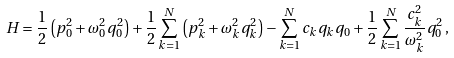Convert formula to latex. <formula><loc_0><loc_0><loc_500><loc_500>H = \frac { 1 } { 2 } \left ( p _ { 0 } ^ { 2 } + \omega _ { 0 } ^ { 2 } q _ { 0 } ^ { 2 } \right ) + \frac { 1 } { 2 } \sum _ { k = 1 } ^ { N } \left ( p _ { k } ^ { 2 } + \omega _ { k } ^ { 2 } q _ { k } ^ { 2 } \right ) - \sum _ { k = 1 } ^ { N } c _ { k } q _ { k } q _ { 0 } + \frac { 1 } { 2 } \sum _ { k = 1 } ^ { N } \frac { c _ { k } ^ { 2 } } { \omega _ { k } ^ { 2 } } q _ { 0 } ^ { 2 } \, ,</formula> 